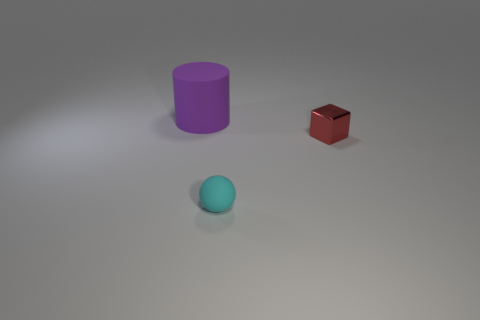What shape is the object left of the object in front of the small red thing?
Ensure brevity in your answer.  Cylinder. Is there anything else that is the same color as the small cube?
Give a very brief answer. No. There is a purple cylinder; does it have the same size as the thing that is to the right of the tiny cyan sphere?
Make the answer very short. No. What number of small things are purple rubber objects or blue rubber cylinders?
Keep it short and to the point. 0. Are there more green cylinders than matte cylinders?
Your answer should be very brief. No. There is a purple rubber cylinder behind the object that is in front of the tiny shiny cube; what number of small red objects are behind it?
Provide a short and direct response. 0. What is the shape of the red object?
Your response must be concise. Cube. How many other things are there of the same material as the purple thing?
Offer a terse response. 1. Does the matte cylinder have the same size as the cyan rubber object?
Your response must be concise. No. What shape is the matte object that is right of the large purple cylinder?
Keep it short and to the point. Sphere. 